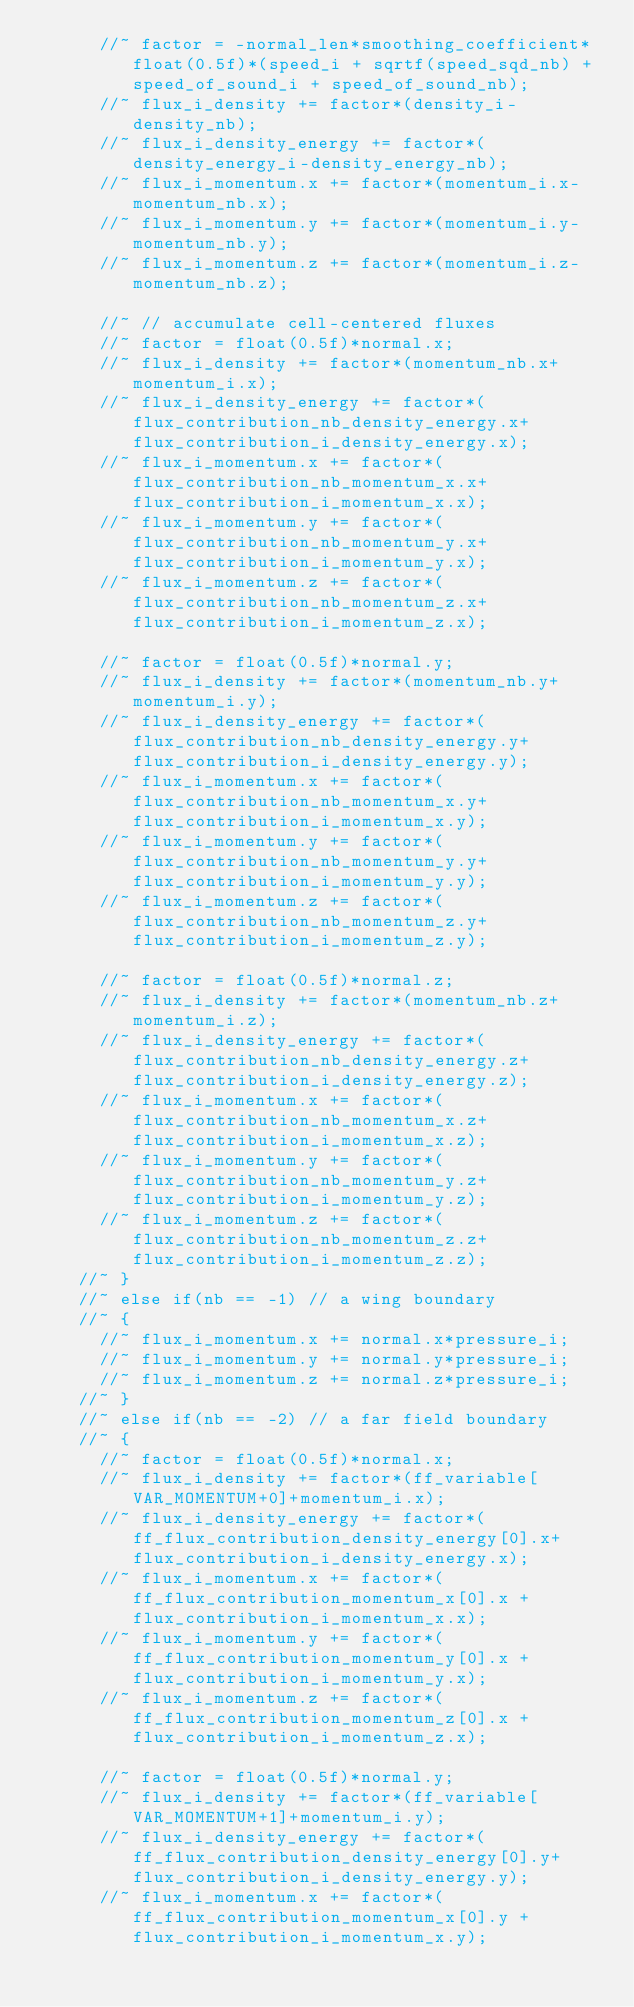<code> <loc_0><loc_0><loc_500><loc_500><_Cuda_>			//~ factor = -normal_len*smoothing_coefficient*float(0.5f)*(speed_i + sqrtf(speed_sqd_nb) + speed_of_sound_i + speed_of_sound_nb);
			//~ flux_i_density += factor*(density_i-density_nb);
			//~ flux_i_density_energy += factor*(density_energy_i-density_energy_nb);
			//~ flux_i_momentum.x += factor*(momentum_i.x-momentum_nb.x);
			//~ flux_i_momentum.y += factor*(momentum_i.y-momentum_nb.y);
			//~ flux_i_momentum.z += factor*(momentum_i.z-momentum_nb.z);

			//~ // accumulate cell-centered fluxes
			//~ factor = float(0.5f)*normal.x;
			//~ flux_i_density += factor*(momentum_nb.x+momentum_i.x);
			//~ flux_i_density_energy += factor*(flux_contribution_nb_density_energy.x+flux_contribution_i_density_energy.x);
			//~ flux_i_momentum.x += factor*(flux_contribution_nb_momentum_x.x+flux_contribution_i_momentum_x.x);
			//~ flux_i_momentum.y += factor*(flux_contribution_nb_momentum_y.x+flux_contribution_i_momentum_y.x);
			//~ flux_i_momentum.z += factor*(flux_contribution_nb_momentum_z.x+flux_contribution_i_momentum_z.x);
			
			//~ factor = float(0.5f)*normal.y;
			//~ flux_i_density += factor*(momentum_nb.y+momentum_i.y);
			//~ flux_i_density_energy += factor*(flux_contribution_nb_density_energy.y+flux_contribution_i_density_energy.y);
			//~ flux_i_momentum.x += factor*(flux_contribution_nb_momentum_x.y+flux_contribution_i_momentum_x.y);
			//~ flux_i_momentum.y += factor*(flux_contribution_nb_momentum_y.y+flux_contribution_i_momentum_y.y);
			//~ flux_i_momentum.z += factor*(flux_contribution_nb_momentum_z.y+flux_contribution_i_momentum_z.y);
			
			//~ factor = float(0.5f)*normal.z;
			//~ flux_i_density += factor*(momentum_nb.z+momentum_i.z);
			//~ flux_i_density_energy += factor*(flux_contribution_nb_density_energy.z+flux_contribution_i_density_energy.z);
			//~ flux_i_momentum.x += factor*(flux_contribution_nb_momentum_x.z+flux_contribution_i_momentum_x.z);
			//~ flux_i_momentum.y += factor*(flux_contribution_nb_momentum_y.z+flux_contribution_i_momentum_y.z);
			//~ flux_i_momentum.z += factor*(flux_contribution_nb_momentum_z.z+flux_contribution_i_momentum_z.z);
		//~ }
		//~ else if(nb == -1)	// a wing boundary
		//~ {
			//~ flux_i_momentum.x += normal.x*pressure_i;
			//~ flux_i_momentum.y += normal.y*pressure_i;
			//~ flux_i_momentum.z += normal.z*pressure_i;
		//~ }
		//~ else if(nb == -2) // a far field boundary
		//~ {
			//~ factor = float(0.5f)*normal.x;
			//~ flux_i_density += factor*(ff_variable[VAR_MOMENTUM+0]+momentum_i.x);
			//~ flux_i_density_energy += factor*(ff_flux_contribution_density_energy[0].x+flux_contribution_i_density_energy.x);
			//~ flux_i_momentum.x += factor*(ff_flux_contribution_momentum_x[0].x + flux_contribution_i_momentum_x.x);
			//~ flux_i_momentum.y += factor*(ff_flux_contribution_momentum_y[0].x + flux_contribution_i_momentum_y.x);
			//~ flux_i_momentum.z += factor*(ff_flux_contribution_momentum_z[0].x + flux_contribution_i_momentum_z.x);
			
			//~ factor = float(0.5f)*normal.y;
			//~ flux_i_density += factor*(ff_variable[VAR_MOMENTUM+1]+momentum_i.y);
			//~ flux_i_density_energy += factor*(ff_flux_contribution_density_energy[0].y+flux_contribution_i_density_energy.y);
			//~ flux_i_momentum.x += factor*(ff_flux_contribution_momentum_x[0].y + flux_contribution_i_momentum_x.y);</code> 